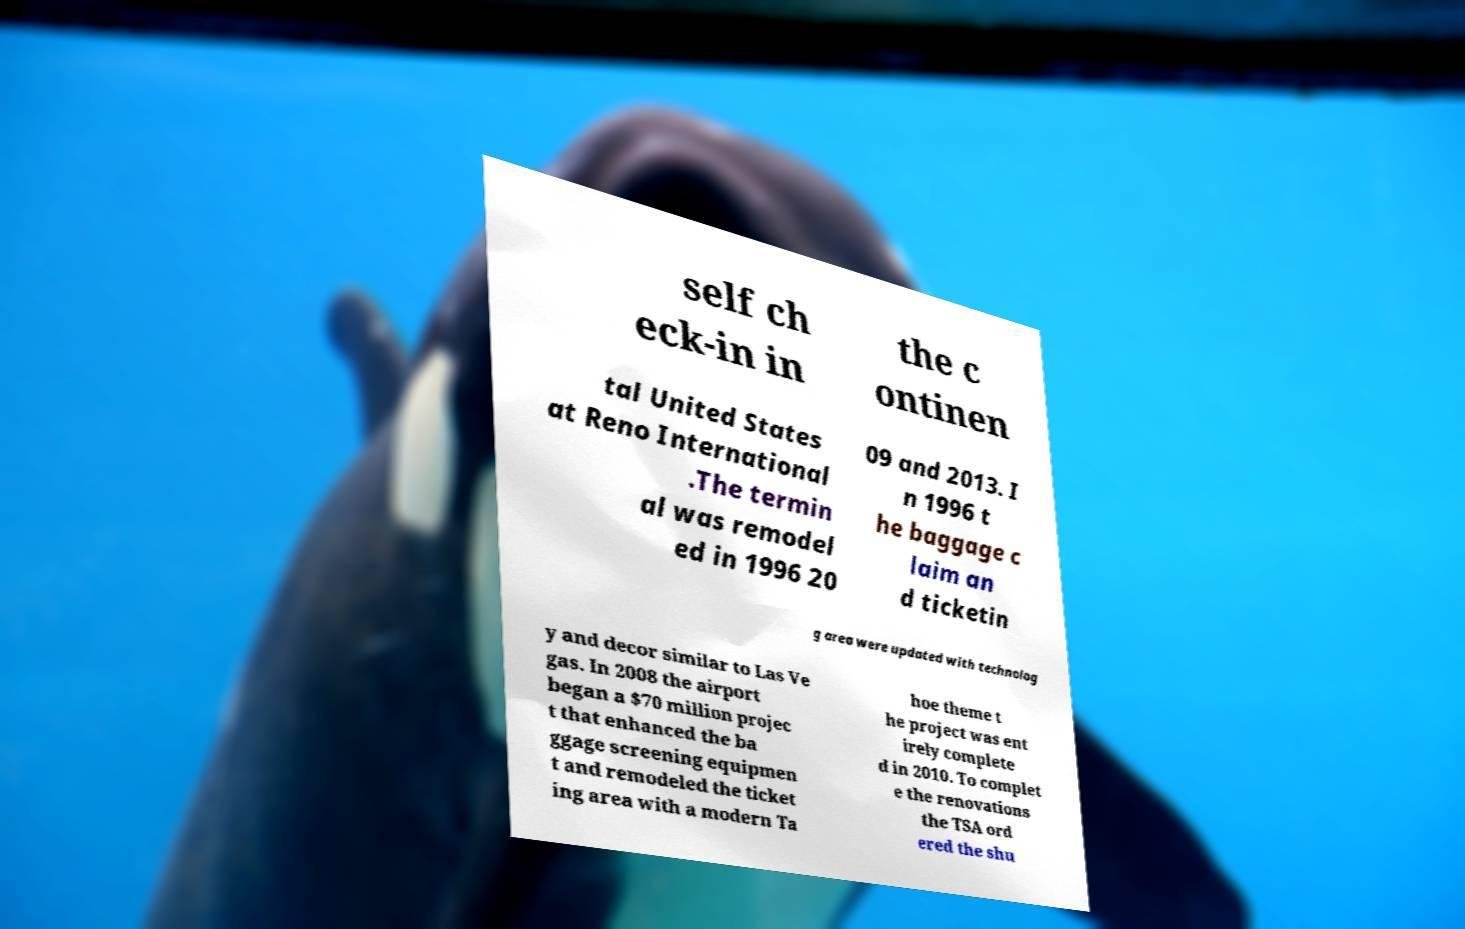Can you read and provide the text displayed in the image?This photo seems to have some interesting text. Can you extract and type it out for me? self ch eck-in in the c ontinen tal United States at Reno International .The termin al was remodel ed in 1996 20 09 and 2013. I n 1996 t he baggage c laim an d ticketin g area were updated with technolog y and decor similar to Las Ve gas. In 2008 the airport began a $70 million projec t that enhanced the ba ggage screening equipmen t and remodeled the ticket ing area with a modern Ta hoe theme t he project was ent irely complete d in 2010. To complet e the renovations the TSA ord ered the shu 